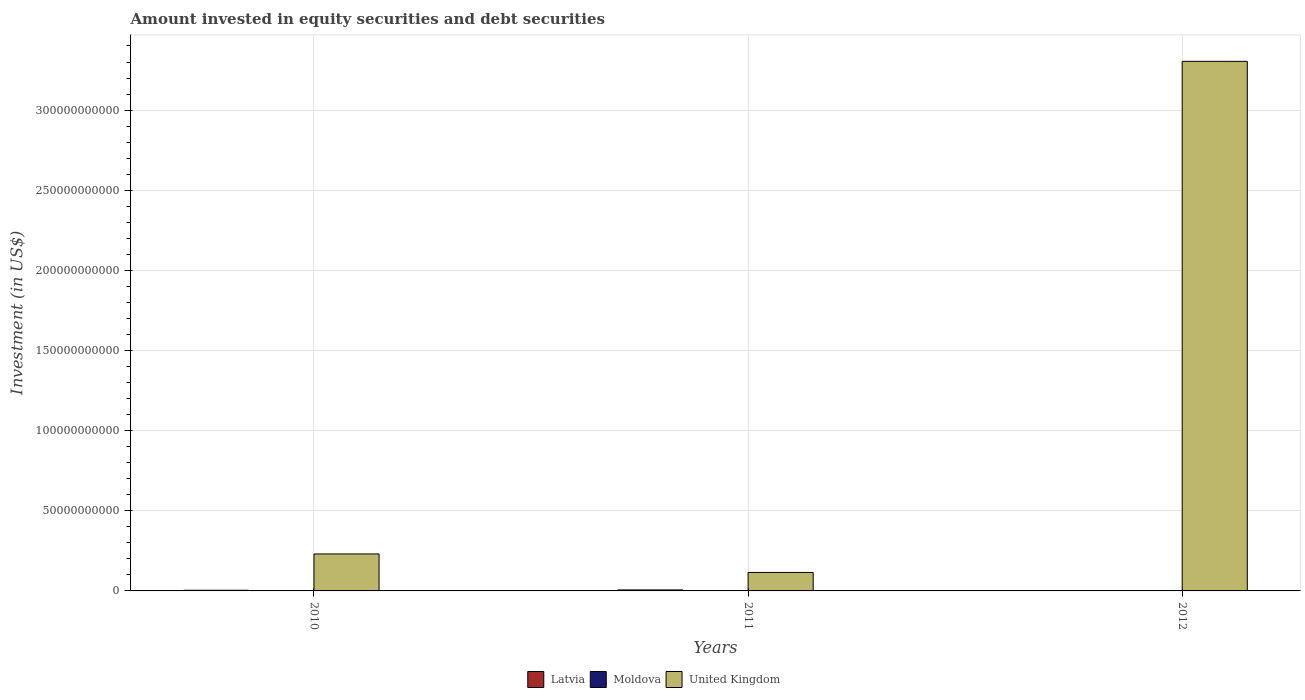In how many cases, is the number of bars for a given year not equal to the number of legend labels?
Provide a succinct answer. 2. What is the amount invested in equity securities and debt securities in Moldova in 2010?
Ensure brevity in your answer.  0. Across all years, what is the maximum amount invested in equity securities and debt securities in United Kingdom?
Give a very brief answer. 3.30e+11. Across all years, what is the minimum amount invested in equity securities and debt securities in Latvia?
Your answer should be very brief. 0. What is the total amount invested in equity securities and debt securities in United Kingdom in the graph?
Make the answer very short. 3.65e+11. What is the difference between the amount invested in equity securities and debt securities in United Kingdom in 2010 and that in 2011?
Provide a succinct answer. 1.15e+1. What is the difference between the amount invested in equity securities and debt securities in Moldova in 2010 and the amount invested in equity securities and debt securities in Latvia in 2012?
Your answer should be very brief. 0. What is the average amount invested in equity securities and debt securities in United Kingdom per year?
Your answer should be compact. 1.22e+11. In the year 2011, what is the difference between the amount invested in equity securities and debt securities in Moldova and amount invested in equity securities and debt securities in United Kingdom?
Offer a very short reply. -1.15e+1. In how many years, is the amount invested in equity securities and debt securities in Latvia greater than 60000000000 US$?
Ensure brevity in your answer.  0. What is the ratio of the amount invested in equity securities and debt securities in United Kingdom in 2010 to that in 2011?
Ensure brevity in your answer.  2. Is the amount invested in equity securities and debt securities in United Kingdom in 2010 less than that in 2011?
Ensure brevity in your answer.  No. What is the difference between the highest and the second highest amount invested in equity securities and debt securities in United Kingdom?
Your answer should be compact. 3.07e+11. What is the difference between the highest and the lowest amount invested in equity securities and debt securities in Moldova?
Offer a very short reply. 3.00e+04. In how many years, is the amount invested in equity securities and debt securities in Latvia greater than the average amount invested in equity securities and debt securities in Latvia taken over all years?
Your response must be concise. 2. How many years are there in the graph?
Make the answer very short. 3. Does the graph contain grids?
Your answer should be compact. Yes. How many legend labels are there?
Your response must be concise. 3. What is the title of the graph?
Provide a succinct answer. Amount invested in equity securities and debt securities. Does "St. Lucia" appear as one of the legend labels in the graph?
Your response must be concise. No. What is the label or title of the Y-axis?
Make the answer very short. Investment (in US$). What is the Investment (in US$) of Latvia in 2010?
Provide a succinct answer. 4.13e+08. What is the Investment (in US$) of Moldova in 2010?
Make the answer very short. 0. What is the Investment (in US$) in United Kingdom in 2010?
Offer a very short reply. 2.31e+1. What is the Investment (in US$) of Latvia in 2011?
Give a very brief answer. 6.20e+08. What is the Investment (in US$) of Moldova in 2011?
Ensure brevity in your answer.  3.00e+04. What is the Investment (in US$) in United Kingdom in 2011?
Provide a short and direct response. 1.15e+1. What is the Investment (in US$) in Latvia in 2012?
Your response must be concise. 0. What is the Investment (in US$) of Moldova in 2012?
Make the answer very short. 0. What is the Investment (in US$) in United Kingdom in 2012?
Provide a succinct answer. 3.30e+11. Across all years, what is the maximum Investment (in US$) of Latvia?
Ensure brevity in your answer.  6.20e+08. Across all years, what is the maximum Investment (in US$) of Moldova?
Provide a succinct answer. 3.00e+04. Across all years, what is the maximum Investment (in US$) in United Kingdom?
Provide a short and direct response. 3.30e+11. Across all years, what is the minimum Investment (in US$) in United Kingdom?
Provide a succinct answer. 1.15e+1. What is the total Investment (in US$) of Latvia in the graph?
Give a very brief answer. 1.03e+09. What is the total Investment (in US$) in Moldova in the graph?
Ensure brevity in your answer.  3.00e+04. What is the total Investment (in US$) in United Kingdom in the graph?
Your answer should be compact. 3.65e+11. What is the difference between the Investment (in US$) of Latvia in 2010 and that in 2011?
Ensure brevity in your answer.  -2.07e+08. What is the difference between the Investment (in US$) in United Kingdom in 2010 and that in 2011?
Give a very brief answer. 1.15e+1. What is the difference between the Investment (in US$) of United Kingdom in 2010 and that in 2012?
Give a very brief answer. -3.07e+11. What is the difference between the Investment (in US$) of United Kingdom in 2011 and that in 2012?
Make the answer very short. -3.19e+11. What is the difference between the Investment (in US$) of Latvia in 2010 and the Investment (in US$) of Moldova in 2011?
Your response must be concise. 4.13e+08. What is the difference between the Investment (in US$) in Latvia in 2010 and the Investment (in US$) in United Kingdom in 2011?
Offer a very short reply. -1.11e+1. What is the difference between the Investment (in US$) of Latvia in 2010 and the Investment (in US$) of United Kingdom in 2012?
Provide a short and direct response. -3.30e+11. What is the difference between the Investment (in US$) of Latvia in 2011 and the Investment (in US$) of United Kingdom in 2012?
Give a very brief answer. -3.30e+11. What is the difference between the Investment (in US$) in Moldova in 2011 and the Investment (in US$) in United Kingdom in 2012?
Your answer should be compact. -3.30e+11. What is the average Investment (in US$) of Latvia per year?
Your answer should be very brief. 3.44e+08. What is the average Investment (in US$) of Moldova per year?
Offer a terse response. 10000. What is the average Investment (in US$) in United Kingdom per year?
Provide a succinct answer. 1.22e+11. In the year 2010, what is the difference between the Investment (in US$) in Latvia and Investment (in US$) in United Kingdom?
Offer a very short reply. -2.27e+1. In the year 2011, what is the difference between the Investment (in US$) in Latvia and Investment (in US$) in Moldova?
Your response must be concise. 6.20e+08. In the year 2011, what is the difference between the Investment (in US$) in Latvia and Investment (in US$) in United Kingdom?
Make the answer very short. -1.09e+1. In the year 2011, what is the difference between the Investment (in US$) in Moldova and Investment (in US$) in United Kingdom?
Offer a terse response. -1.15e+1. What is the ratio of the Investment (in US$) in Latvia in 2010 to that in 2011?
Your answer should be very brief. 0.67. What is the ratio of the Investment (in US$) of United Kingdom in 2010 to that in 2011?
Keep it short and to the point. 2. What is the ratio of the Investment (in US$) of United Kingdom in 2010 to that in 2012?
Ensure brevity in your answer.  0.07. What is the ratio of the Investment (in US$) of United Kingdom in 2011 to that in 2012?
Your response must be concise. 0.03. What is the difference between the highest and the second highest Investment (in US$) of United Kingdom?
Ensure brevity in your answer.  3.07e+11. What is the difference between the highest and the lowest Investment (in US$) in Latvia?
Offer a very short reply. 6.20e+08. What is the difference between the highest and the lowest Investment (in US$) in Moldova?
Your response must be concise. 3.00e+04. What is the difference between the highest and the lowest Investment (in US$) in United Kingdom?
Provide a short and direct response. 3.19e+11. 